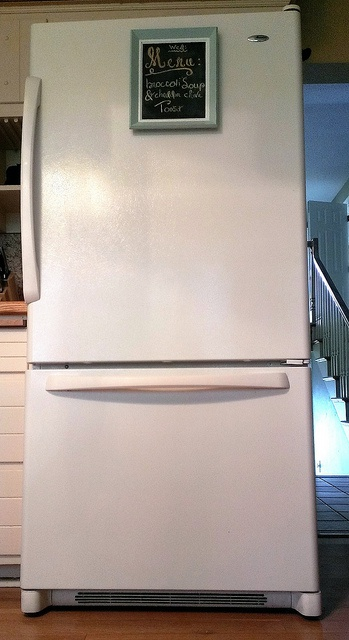Describe the objects in this image and their specific colors. I can see a refrigerator in black, darkgray, and lightgray tones in this image. 